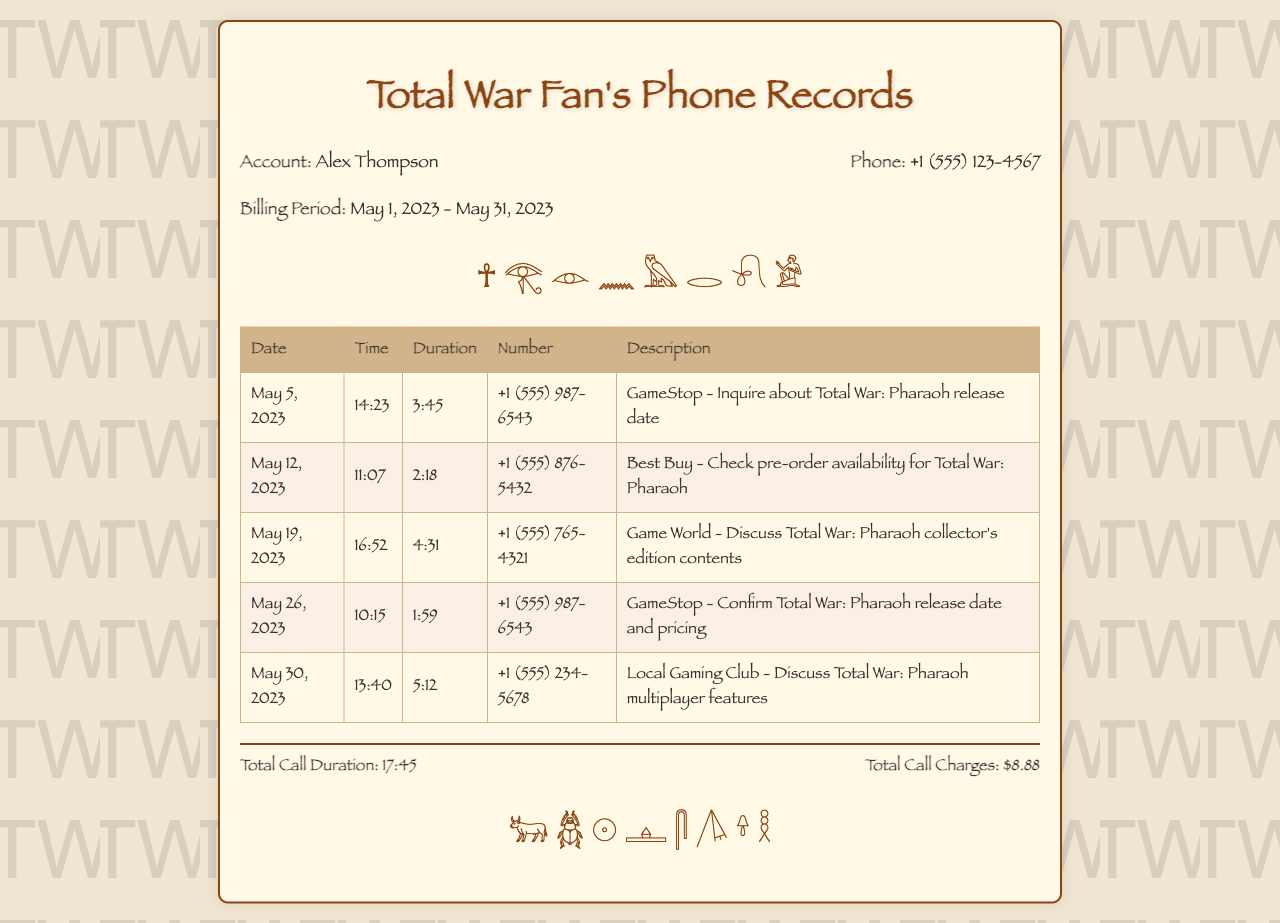What is the name of the account holder? The account holder's name is stated at the top of the document as Alex Thompson.
Answer: Alex Thompson What is the phone number listed in the records? The phone number is provided in the account information section of the document.
Answer: +1 (555) 123-4567 What was the duration of the call on May 19, 2023? The duration for this particular call is recorded in the table under the specified date.
Answer: 4:31 Which gaming store was contacted on May 5, 2023? The description of the call on that date refers to GameStop, which is mentioned in the table.
Answer: GameStop How many calls were made to inquire about Total War: Pharaoh? By counting the number of calls related to Total War: Pharaoh in the descriptions, it can be determined that several inquiries were made.
Answer: 4 What is the total call duration listed in the document? The total call duration is summarized at the end of the document, representing the total time spent on calls.
Answer: 17:45 Which feature was discussed during the call on May 30, 2023? The description of the call specifies that multiplayer features were discussed, as noted in the table.
Answer: Multiplayer features What is the total call charge mentioned? The total call charges are stated at the bottom of the document in the summary.
Answer: $8.88 What date was the call made to confirm the release date and pricing? The specific date for this confirmation call can be found in the table, detailing the calls.
Answer: May 26, 2023 